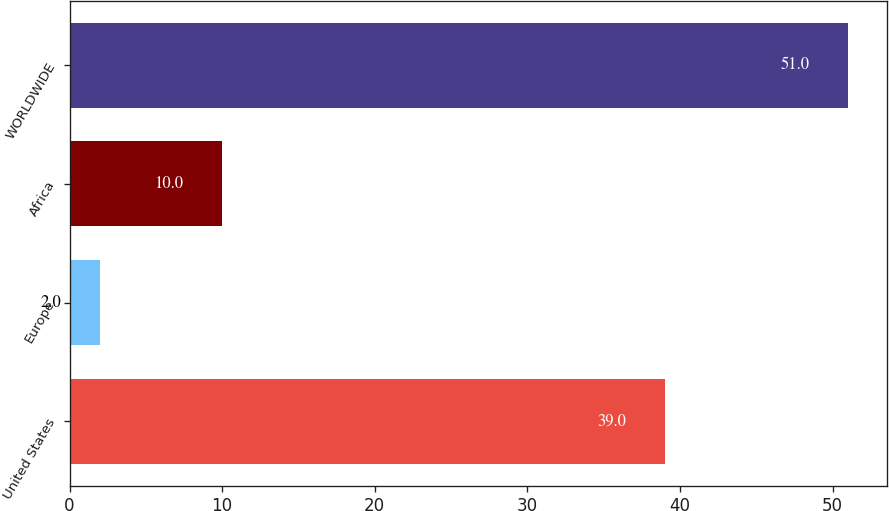<chart> <loc_0><loc_0><loc_500><loc_500><bar_chart><fcel>United States<fcel>Europe<fcel>Africa<fcel>WORLDWIDE<nl><fcel>39<fcel>2<fcel>10<fcel>51<nl></chart> 